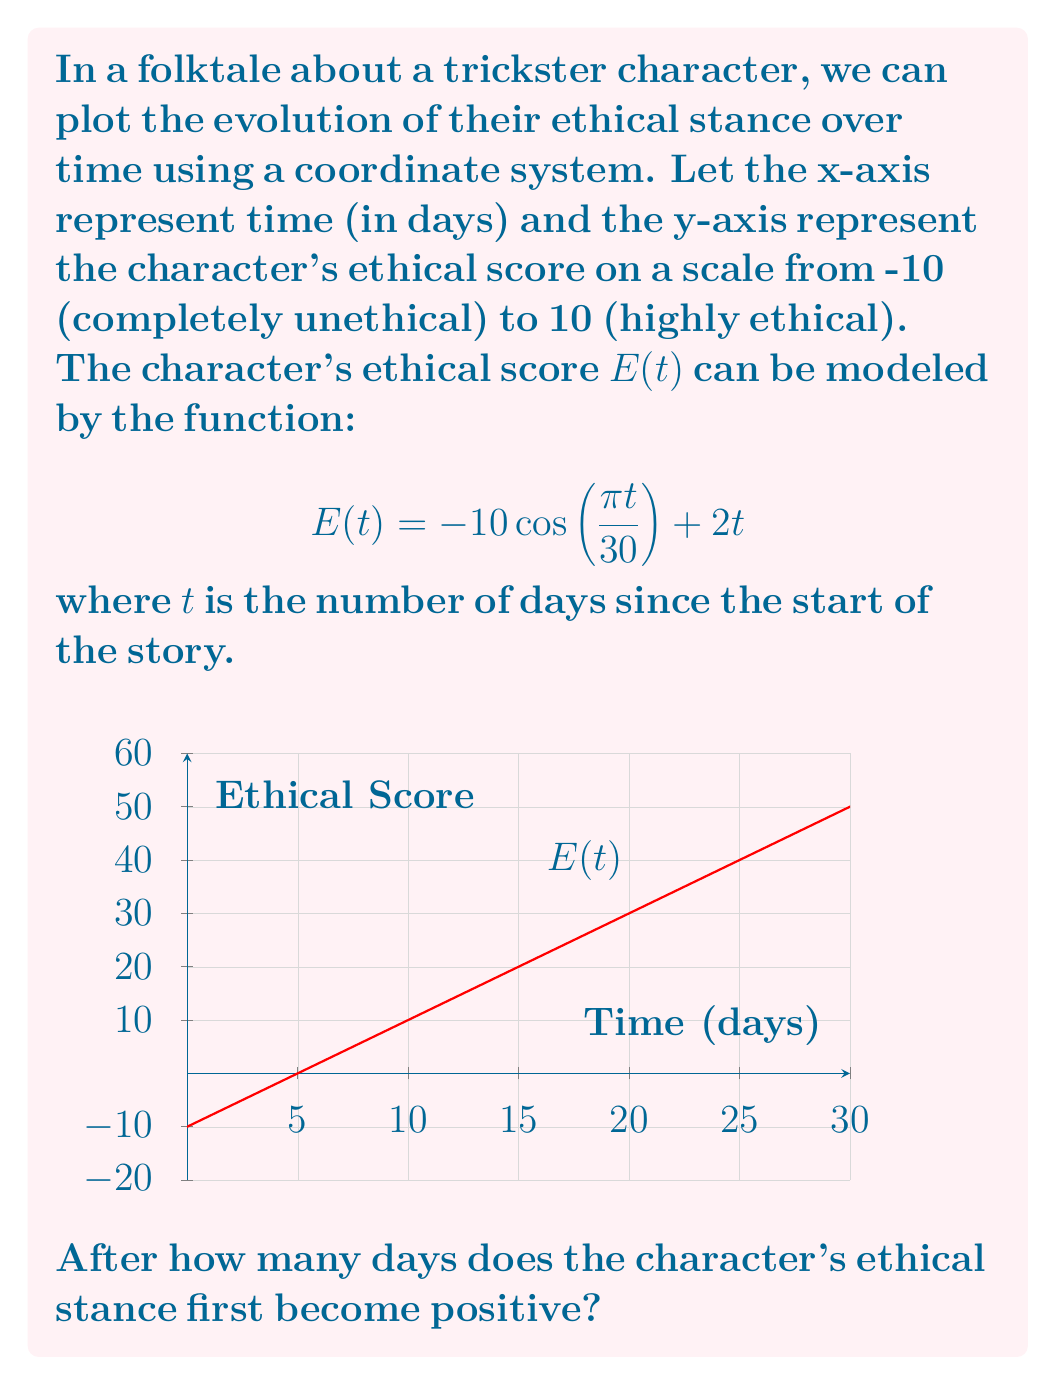Provide a solution to this math problem. To solve this problem, we need to find the first positive value of $t$ where $E(t) = 0$. Let's approach this step-by-step:

1) We need to solve the equation:
   $$-10 \cos(\frac{\pi t}{30}) + 2t = 0$$

2) Rearranging the equation:
   $$10 \cos(\frac{\pi t}{30}) = 2t$$

3) This equation is transcendental and cannot be solved algebraically. We need to use a numerical method or graphical approach.

4) Observing the graph, we can see that the function crosses the x-axis slightly before $t = 5$.

5) We can verify this by testing values:
   At $t = 4$: $E(4) = -10 \cos(\frac{\pi \cdot 4}{30}) + 2 \cdot 4 = -10 \cdot 0.9511 + 8 = -1.511$
   At $t = 5$: $E(5) = -10 \cos(\frac{\pi \cdot 5}{30}) + 2 \cdot 5 = -10 \cdot 0.9239 + 10 = 0.761$

6) Therefore, the ethical stance becomes positive between day 4 and day 5.

7) Using a more precise numerical method (like Newton-Raphson), we can find that the exact solution is approximately 4.7124 days.

8) Since we're asked for the number of days and we can't have a fractional day in this context, we round up to the next whole day.
Answer: 5 days 